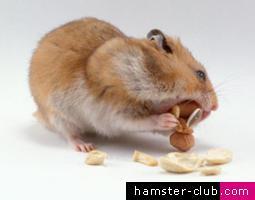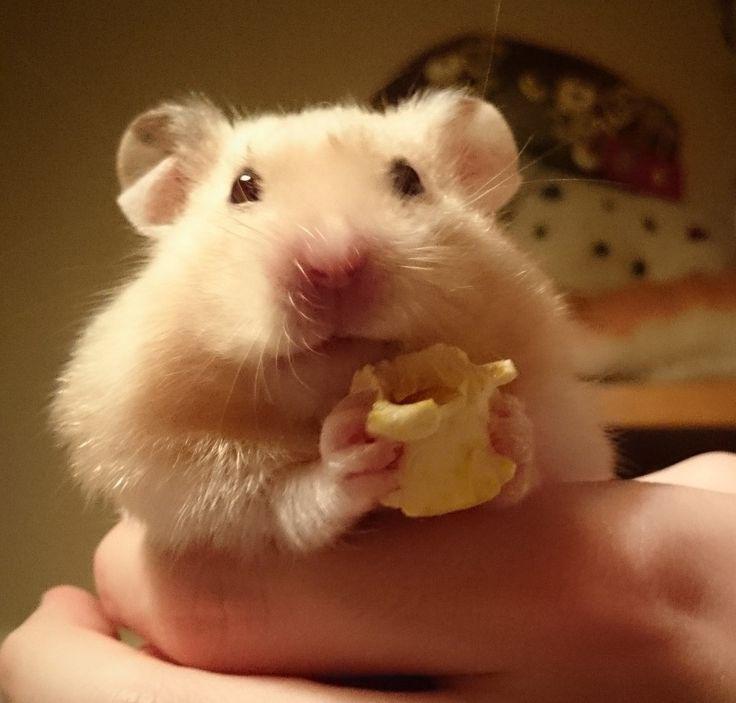The first image is the image on the left, the second image is the image on the right. Given the left and right images, does the statement "Each image shows one hamster with food in front of it, and the right image features a hamster with a peach-colored face clutching a piece of food to its face." hold true? Answer yes or no. Yes. The first image is the image on the left, the second image is the image on the right. Analyze the images presented: Is the assertion "Two hamsters are eating." valid? Answer yes or no. Yes. 